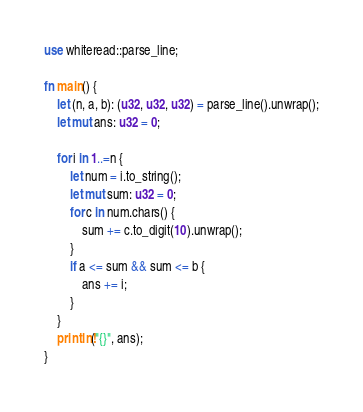<code> <loc_0><loc_0><loc_500><loc_500><_Rust_>use whiteread::parse_line;

fn main() {
    let (n, a, b): (u32, u32, u32) = parse_line().unwrap();
    let mut ans: u32 = 0;

    for i in 1..=n {
        let num = i.to_string();
        let mut sum: u32 = 0;
        for c in num.chars() {
            sum += c.to_digit(10).unwrap();
        }
        if a <= sum && sum <= b {
            ans += i;
        }
    }
    println!("{}", ans);
}
</code> 